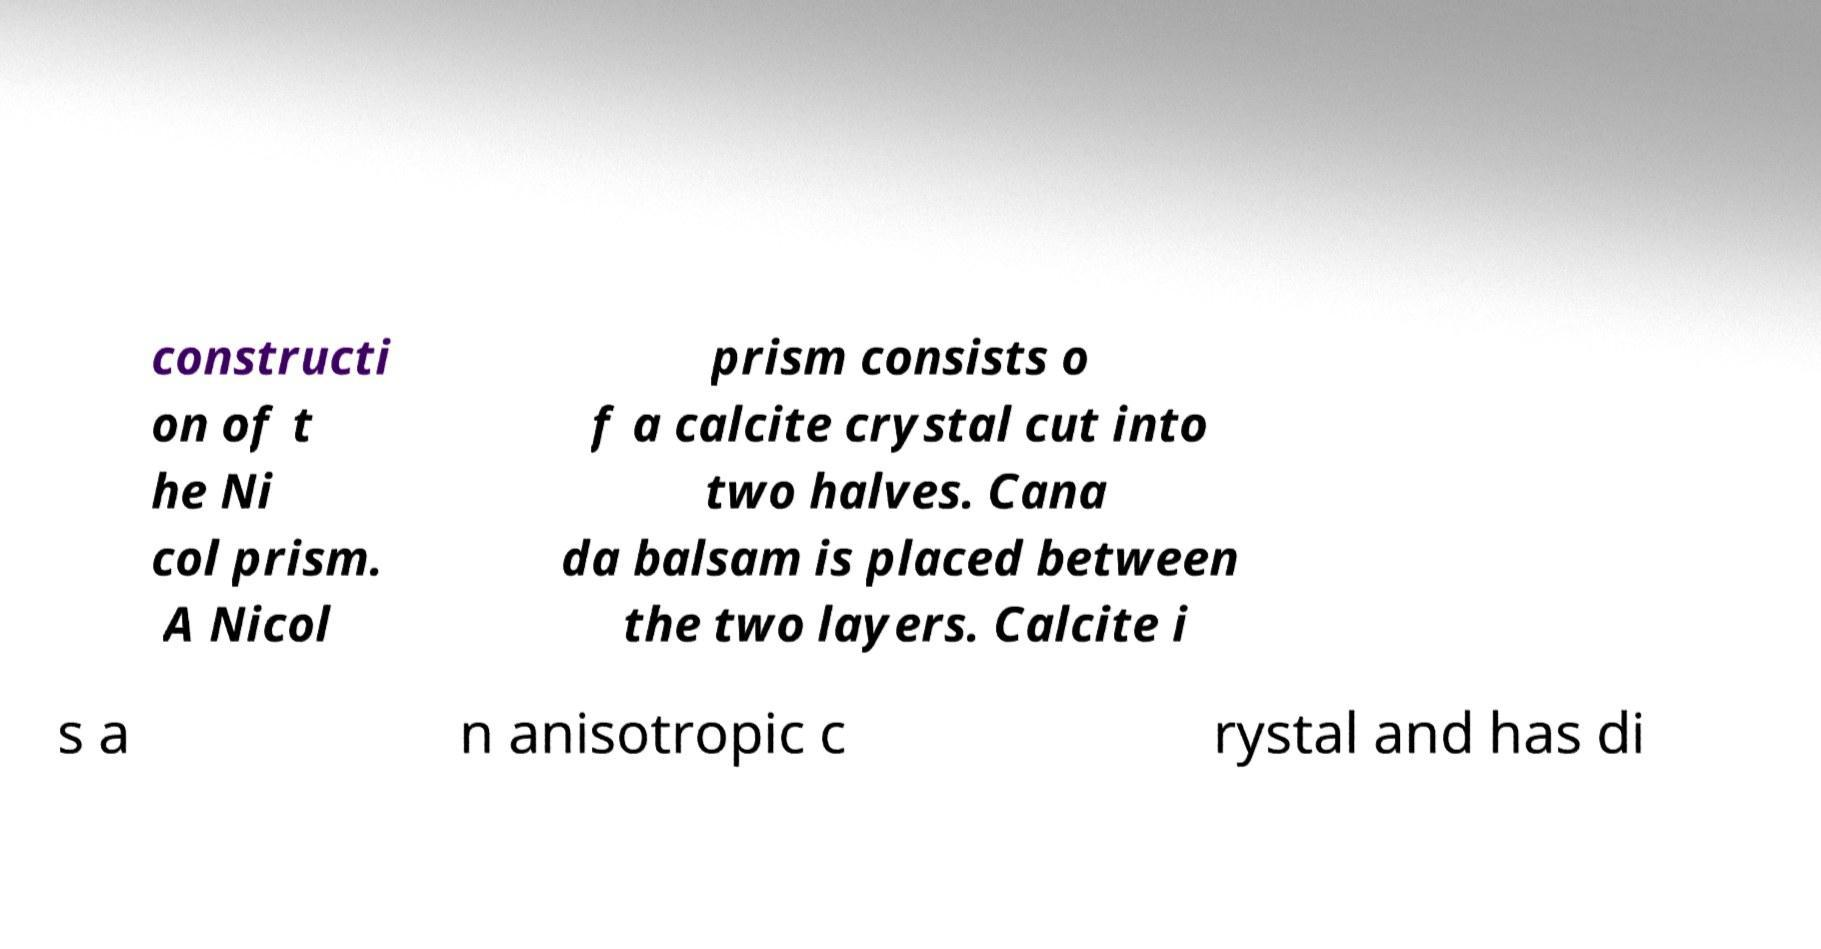What messages or text are displayed in this image? I need them in a readable, typed format. constructi on of t he Ni col prism. A Nicol prism consists o f a calcite crystal cut into two halves. Cana da balsam is placed between the two layers. Calcite i s a n anisotropic c rystal and has di 